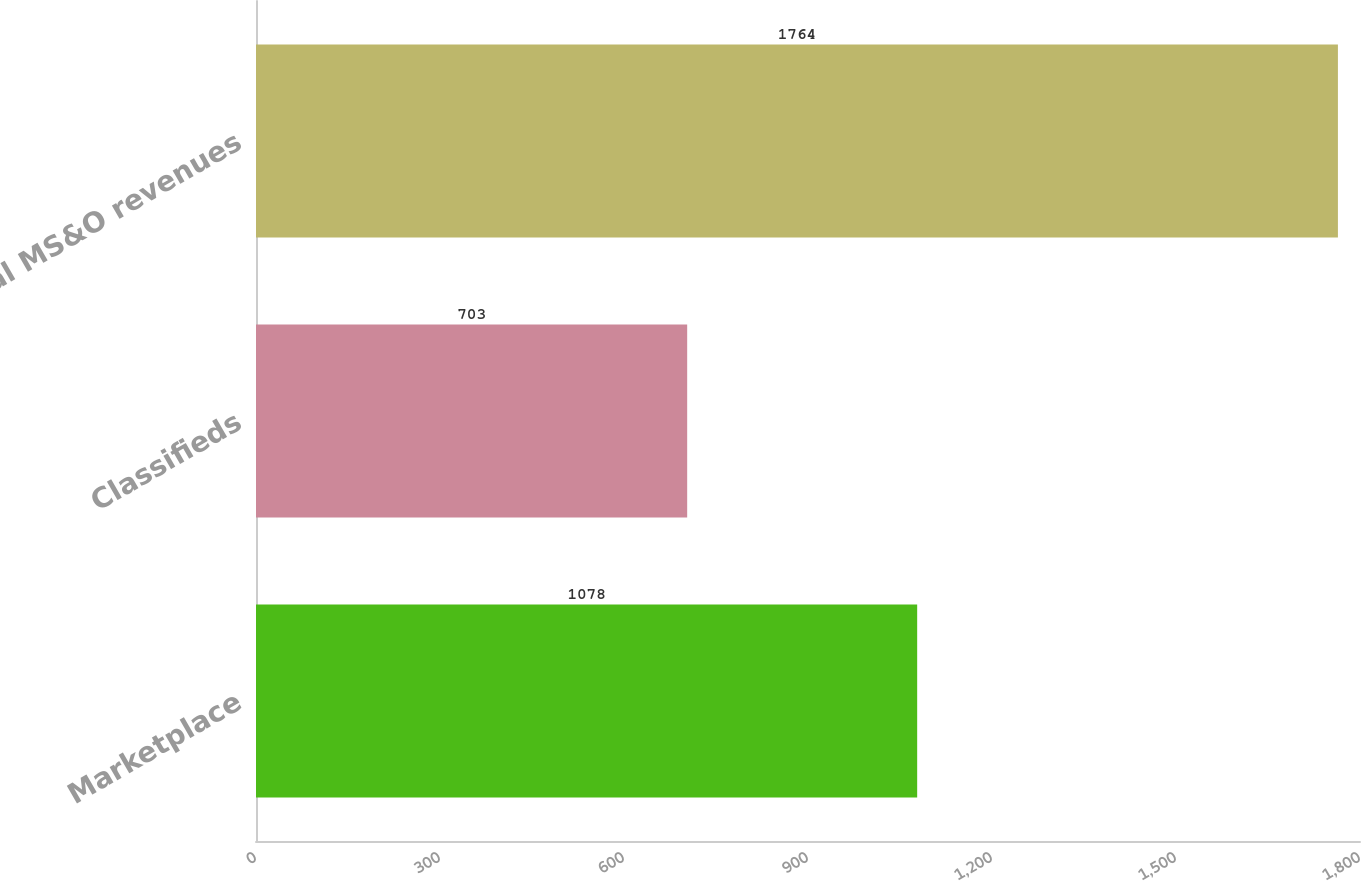Convert chart. <chart><loc_0><loc_0><loc_500><loc_500><bar_chart><fcel>Marketplace<fcel>Classifieds<fcel>Total MS&O revenues<nl><fcel>1078<fcel>703<fcel>1764<nl></chart> 